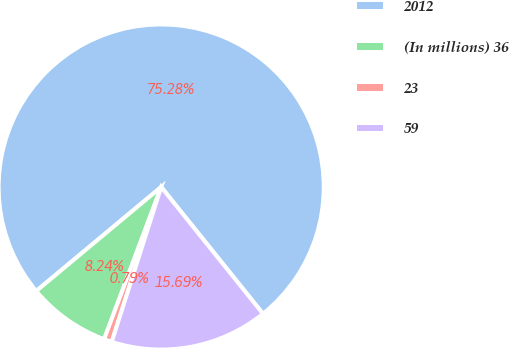Convert chart. <chart><loc_0><loc_0><loc_500><loc_500><pie_chart><fcel>2012<fcel>(In millions) 36<fcel>23<fcel>59<nl><fcel>75.29%<fcel>8.24%<fcel>0.79%<fcel>15.69%<nl></chart> 